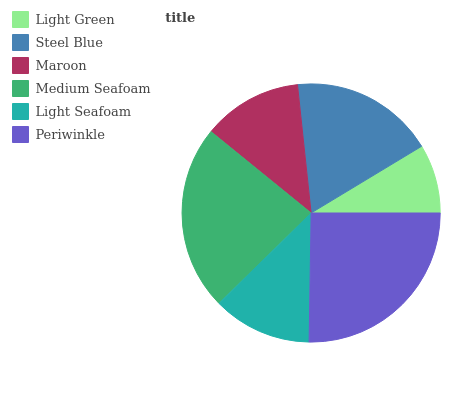Is Light Green the minimum?
Answer yes or no. Yes. Is Periwinkle the maximum?
Answer yes or no. Yes. Is Steel Blue the minimum?
Answer yes or no. No. Is Steel Blue the maximum?
Answer yes or no. No. Is Steel Blue greater than Light Green?
Answer yes or no. Yes. Is Light Green less than Steel Blue?
Answer yes or no. Yes. Is Light Green greater than Steel Blue?
Answer yes or no. No. Is Steel Blue less than Light Green?
Answer yes or no. No. Is Steel Blue the high median?
Answer yes or no. Yes. Is Maroon the low median?
Answer yes or no. Yes. Is Light Seafoam the high median?
Answer yes or no. No. Is Light Seafoam the low median?
Answer yes or no. No. 